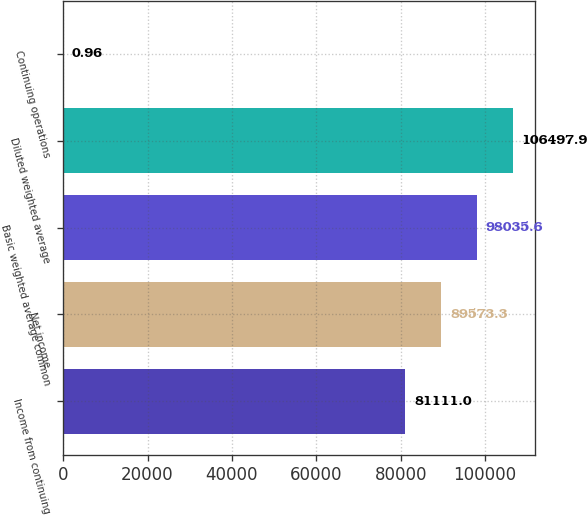Convert chart. <chart><loc_0><loc_0><loc_500><loc_500><bar_chart><fcel>Income from continuing<fcel>Net income<fcel>Basic weighted average common<fcel>Diluted weighted average<fcel>Continuing operations<nl><fcel>81111<fcel>89573.3<fcel>98035.6<fcel>106498<fcel>0.96<nl></chart> 